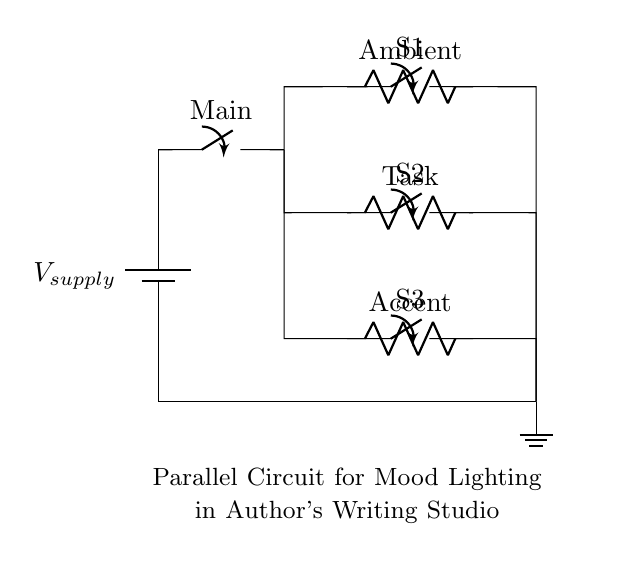What is the type of circuit depicted? The circuit is comprised of multiple components connected in parallel, allowing each branch to operate independently.
Answer: Parallel How many resistors are in the circuit? There are three resistors labeled as Ambient, Task, and Accent. Each of these is connected in a separate branch of the parallel circuit.
Answer: Three What type of switch is used for controlling the lights? The switches used in this circuit diagram are standard single-pole switches that allow the user to turn each lighting branch on or off independently.
Answer: Single-pole What is the purpose of the main switch? The main switch controls the power supply to the entire circuit, allowing the author to turn on or off the mood lighting system as needed.
Answer: Power control Which resistor corresponds to the mood lighting for general ambiance? The resistor labeled as Ambient is responsible for providing general mood lighting in the studio.
Answer: Ambient How are the branches connected to each other? The branches are connected in parallel, which means that the ends of each branch are connected to a shared voltage source, allowing each to function independently.
Answer: Parallel connection What is the purpose of the ground in this circuit? The ground provides a reference point for the electrical circuit, ensuring safety and effective operation by completing the electrical path.
Answer: Safety reference 